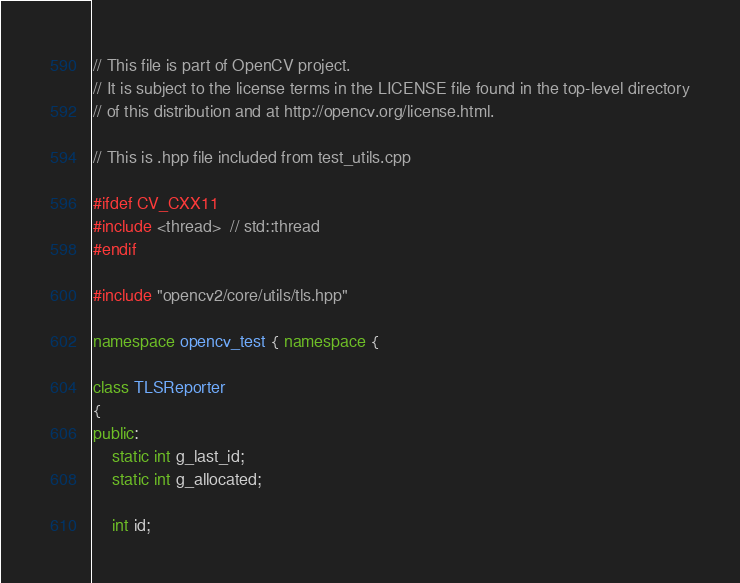<code> <loc_0><loc_0><loc_500><loc_500><_C++_>// This file is part of OpenCV project.
// It is subject to the license terms in the LICENSE file found in the top-level directory
// of this distribution and at http://opencv.org/license.html.

// This is .hpp file included from test_utils.cpp

#ifdef CV_CXX11
#include <thread>  // std::thread
#endif

#include "opencv2/core/utils/tls.hpp"

namespace opencv_test { namespace {

class TLSReporter
{
public:
    static int g_last_id;
    static int g_allocated;

    int id;
</code> 